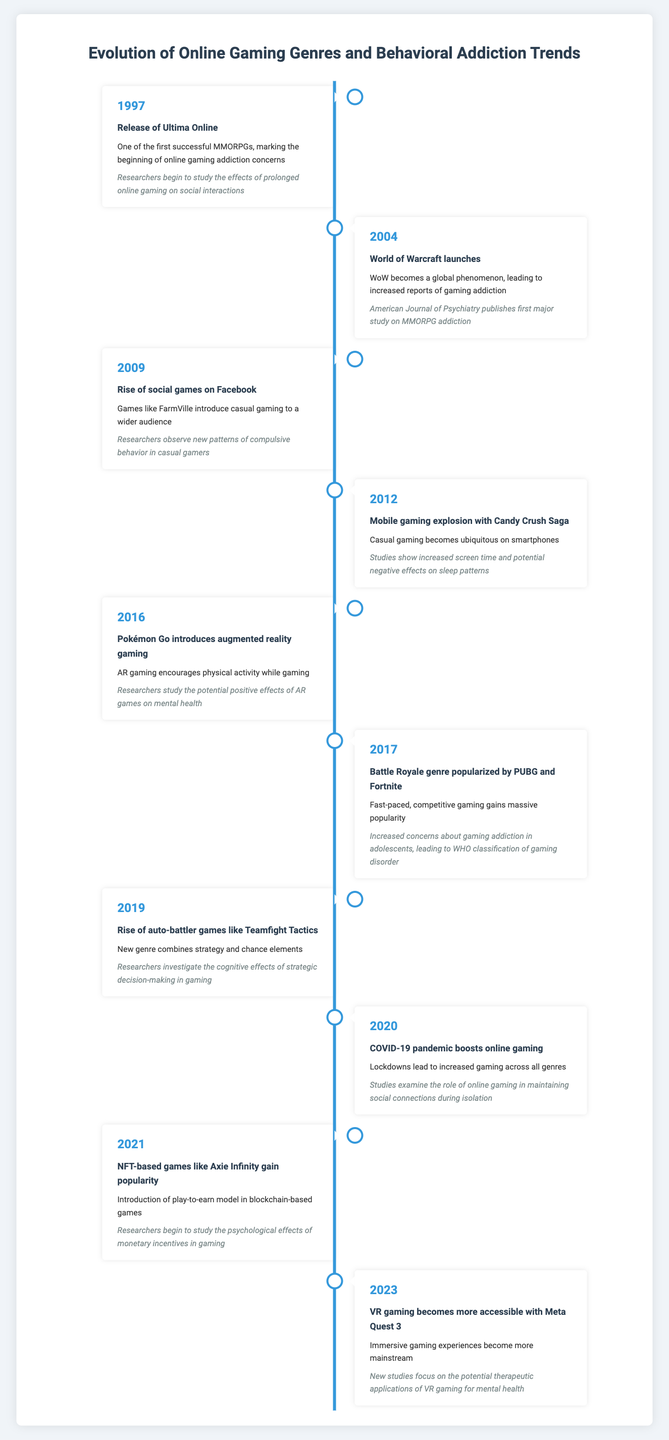What significant online gaming milestone occurred in 1997? The timeline indicates that in 1997, the release of Ultima Online marked one of the first successful MMORPGs and raised concerns about online gaming addiction.
Answer: Release of Ultima Online Which game launch in 2004 led to increased reports of gaming addiction? According to the table, World of Warcraft launched in 2004 and became a global phenomenon, resulting in more reports of gaming addiction.
Answer: World of Warcraft How many years passed between the launch of World of Warcraft and the popularization of the battle royale genre? World of Warcraft launched in 2004, and the battle royale genre gained popularity in 2017. The difference is 2017 - 2004 = 13 years.
Answer: 13 years Did the COVID-19 pandemic lead to an increase in online gaming across all genres? The data states that the COVID-19 pandemic in 2020 caused a boost in online gaming due to lockdowns.
Answer: Yes What trend in gaming occurred in 2019, and how did it differ from previous genres? In 2019, the rise of auto-battler games like Teamfight Tactics introduced a new genre combining strategy and chance, contrasting with the previously popular genres like MMORPGs and battle royales.
Answer: Rise of auto-battler games What was the primary impact observed with the emergence of mobile gaming in 2012? The timeline notes that mobile gaming explosion with Candy Crush Saga in 2012 resulted in increased screen time and potential negative effects on sleep patterns.
Answer: Increased screen time and potential negative effects on sleep What percentage of events in the timeline focused on the impact of gaming on mental health? Out of the ten events listed, three (in 2016, 2021, and 2023) specifically address the relationship between gaming and mental health, which equates to 30%.
Answer: 30% Which popular mobile game was released in 2012, and what behavioral concerns did it raise? The table reveals that Candy Crush Saga, released in 2012, contributed to concerns regarding increased screen time and sleep patterns.
Answer: Candy Crush Saga Based on the timeline data, is it true that researchers began studying gaming behavior trends in the 2000s? The timeline notes significant studies in the 2000s, particularly with World of Warcraft's launch in 2004, confirming that researchers started examining gaming behavior trends during that period.
Answer: Yes 